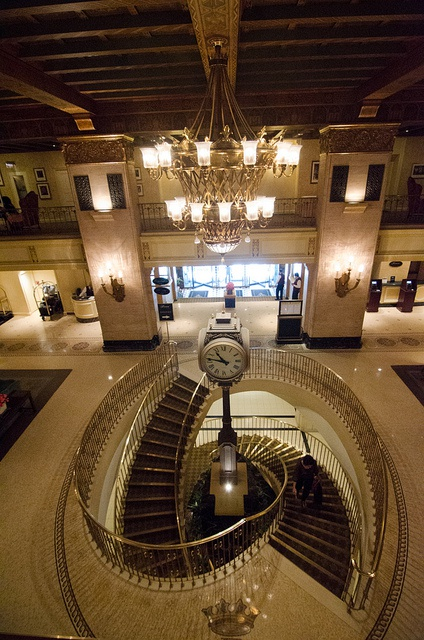Describe the objects in this image and their specific colors. I can see clock in black and gray tones, people in black, navy, gray, and lavender tones, and people in black, darkgray, gray, and navy tones in this image. 